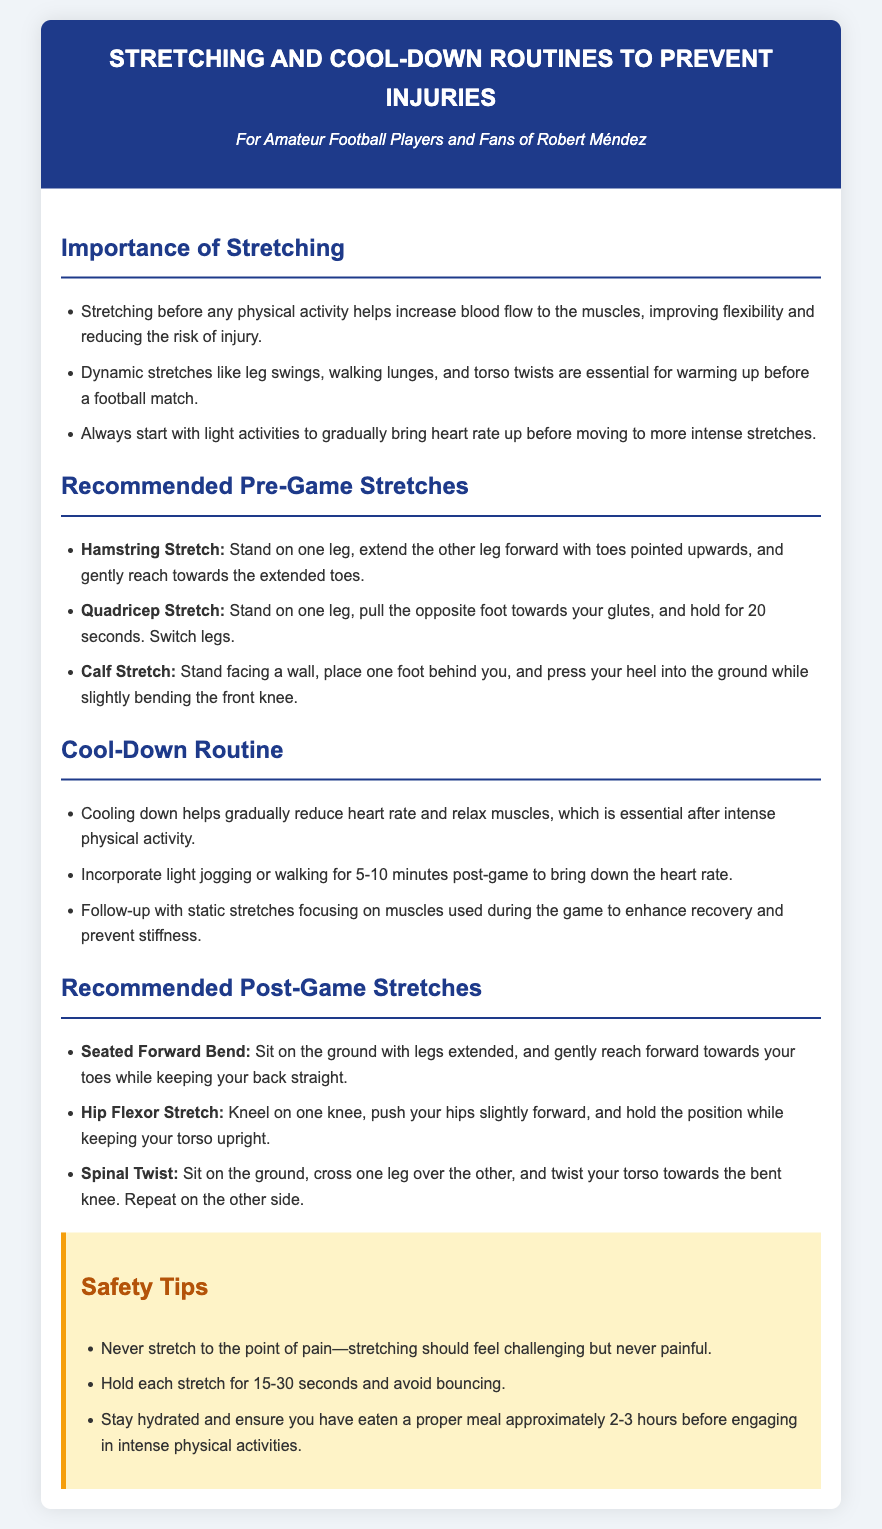What are the benefits of stretching? The document states that stretching helps increase blood flow to the muscles, improving flexibility and reducing the risk of injury.
Answer: Improves flexibility and reduces risk of injury What type of stretches are recommended before a football match? The document lists dynamic stretches like leg swings, walking lunges, and torso twists as essential for warming up.
Answer: Dynamic stretches How long should you hold each stretch? The safety tips advise holding each stretch for 15-30 seconds.
Answer: 15-30 seconds What is a recommended post-game stretch? The document suggests the Seated Forward Bend as a recommended post-game stretch.
Answer: Seated Forward Bend What should you do to cool down after a game? The document recommends incorporating light jogging or walking for 5-10 minutes post-game to reduce heart rate.
Answer: Light jogging or walking for 5-10 minutes Why is it important to warm up gradually? It indicates that starting with light activities helps to gradually bring heart rate up before intense stretches.
Answer: To gradually bring heart rate up What should you avoid while stretching? The document states that you should never stretch to the point of pain and avoid bouncing.
Answer: Stretching to the point of pain What is one thing to ensure before engaging in physical activities? It mentions staying hydrated and eating a proper meal approximately 2-3 hours before intense physical activities.
Answer: Staying hydrated 